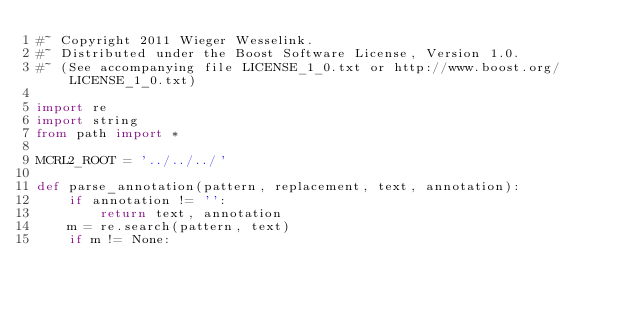<code> <loc_0><loc_0><loc_500><loc_500><_Python_>#~ Copyright 2011 Wieger Wesselink.
#~ Distributed under the Boost Software License, Version 1.0.
#~ (See accompanying file LICENSE_1_0.txt or http://www.boost.org/LICENSE_1_0.txt)

import re
import string
from path import *

MCRL2_ROOT = '../../../'

def parse_annotation(pattern, replacement, text, annotation):
    if annotation != '':
        return text, annotation
    m = re.search(pattern, text)
    if m != None:</code> 